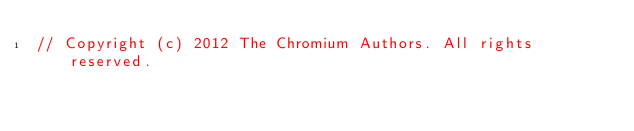<code> <loc_0><loc_0><loc_500><loc_500><_ObjectiveC_>// Copyright (c) 2012 The Chromium Authors. All rights reserved.</code> 